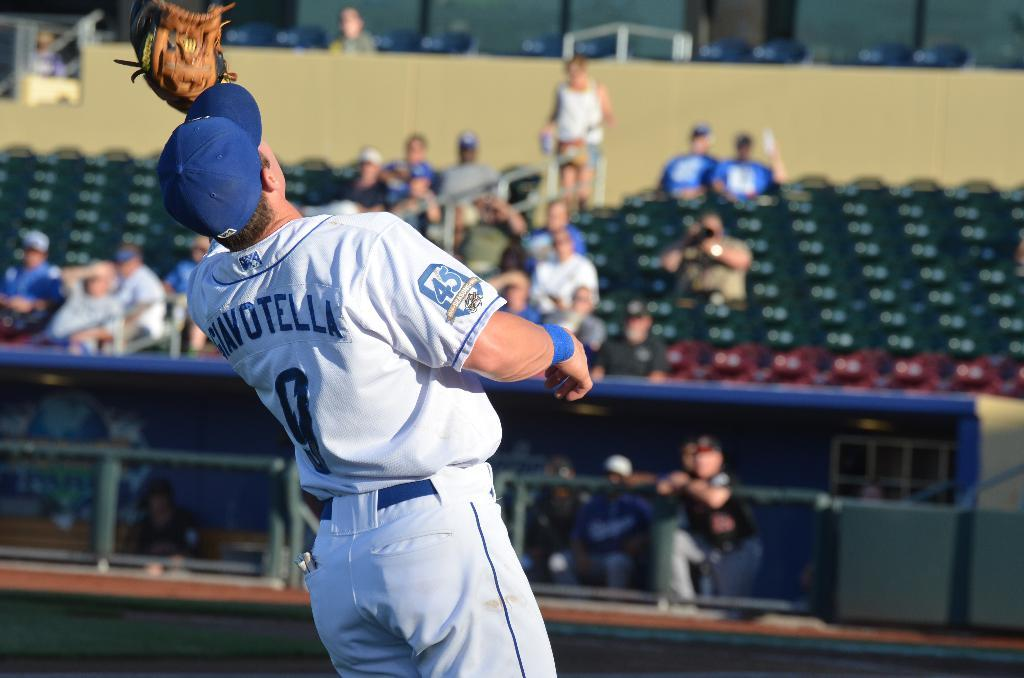Provide a one-sentence caption for the provided image. baseball player number 9 waiting to catch a ball and has 45 anniversary emblem on sleeve. 